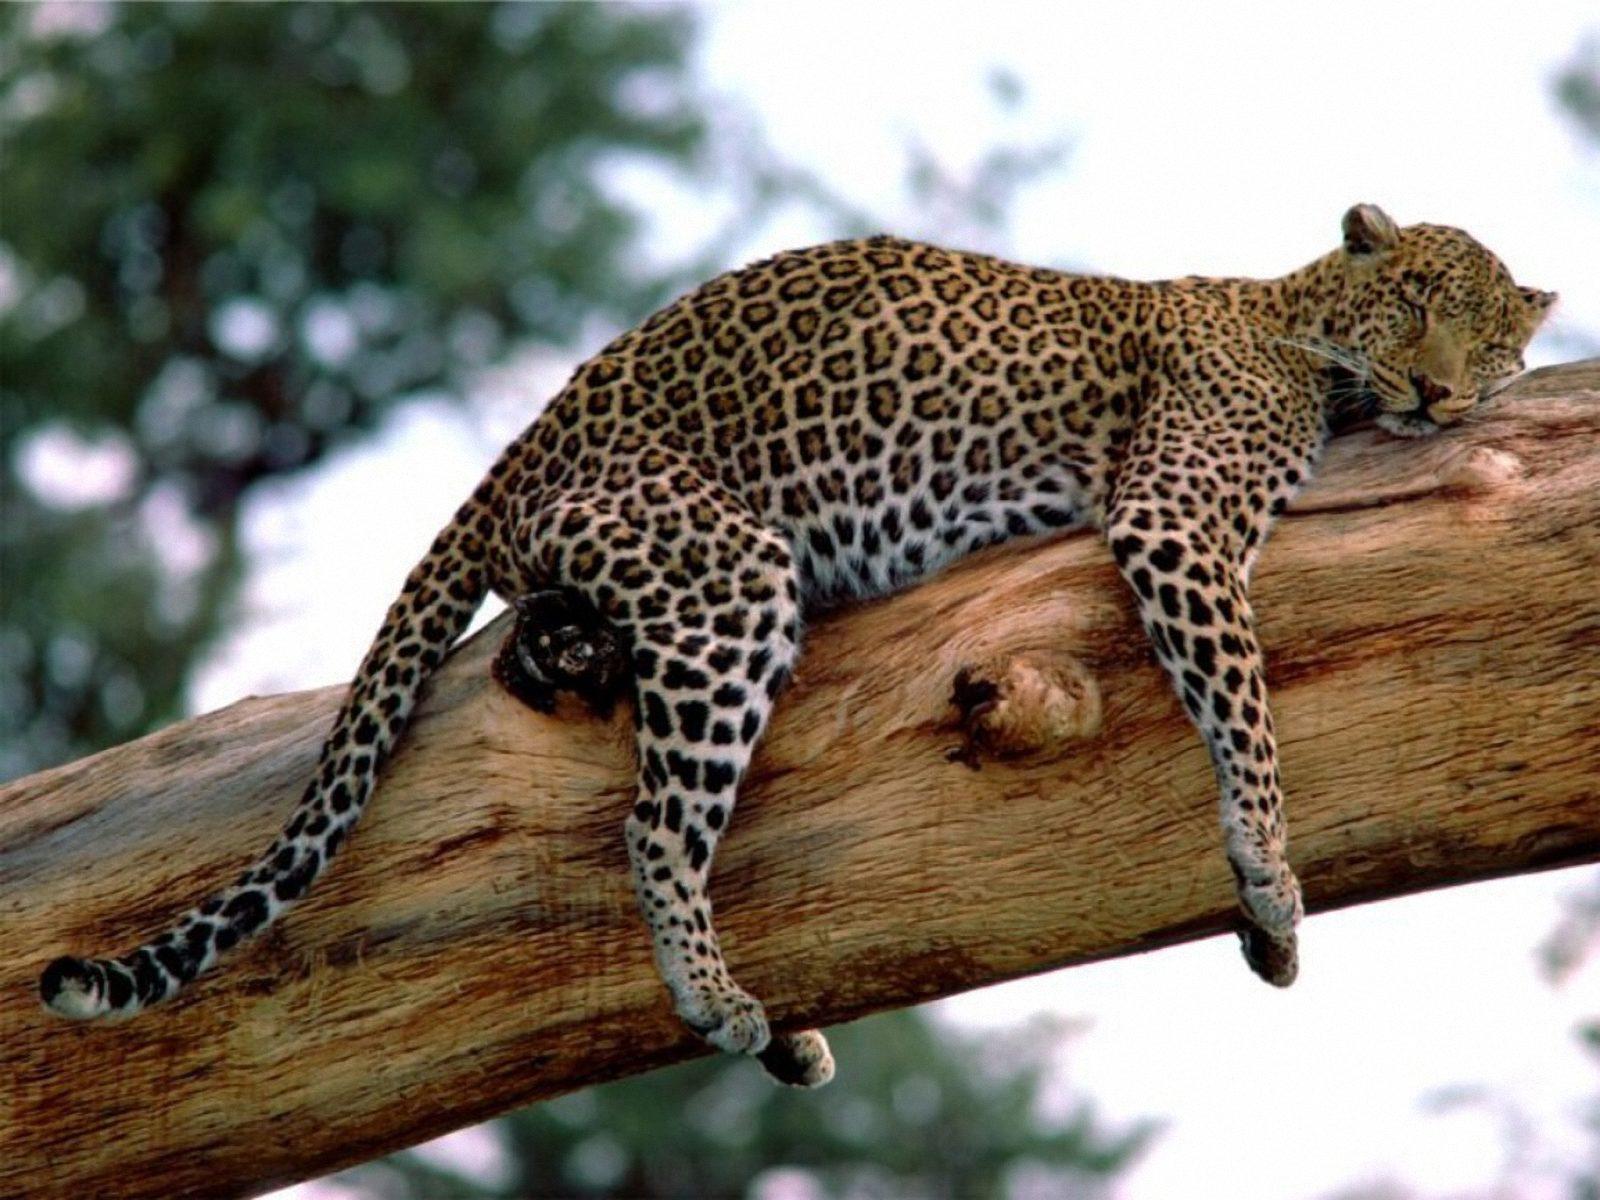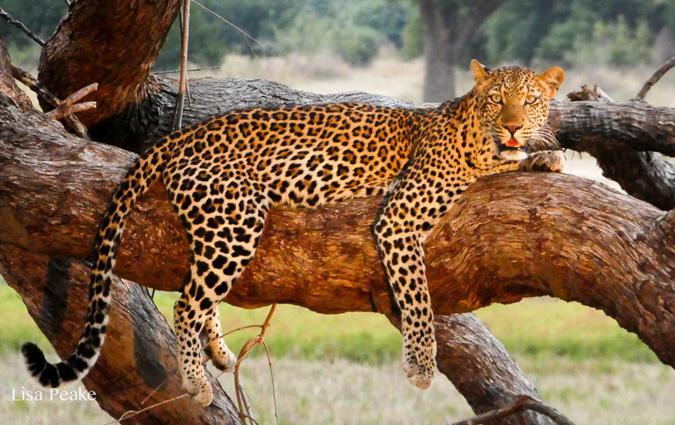The first image is the image on the left, the second image is the image on the right. Analyze the images presented: Is the assertion "Only one of the two leopards is asleep, and neither is showing its tongue." valid? Answer yes or no. No. The first image is the image on the left, the second image is the image on the right. Given the left and right images, does the statement "In at least one image there is a spotted leopard sleeping with his head on a large branch hiding their second ear." hold true? Answer yes or no. No. 